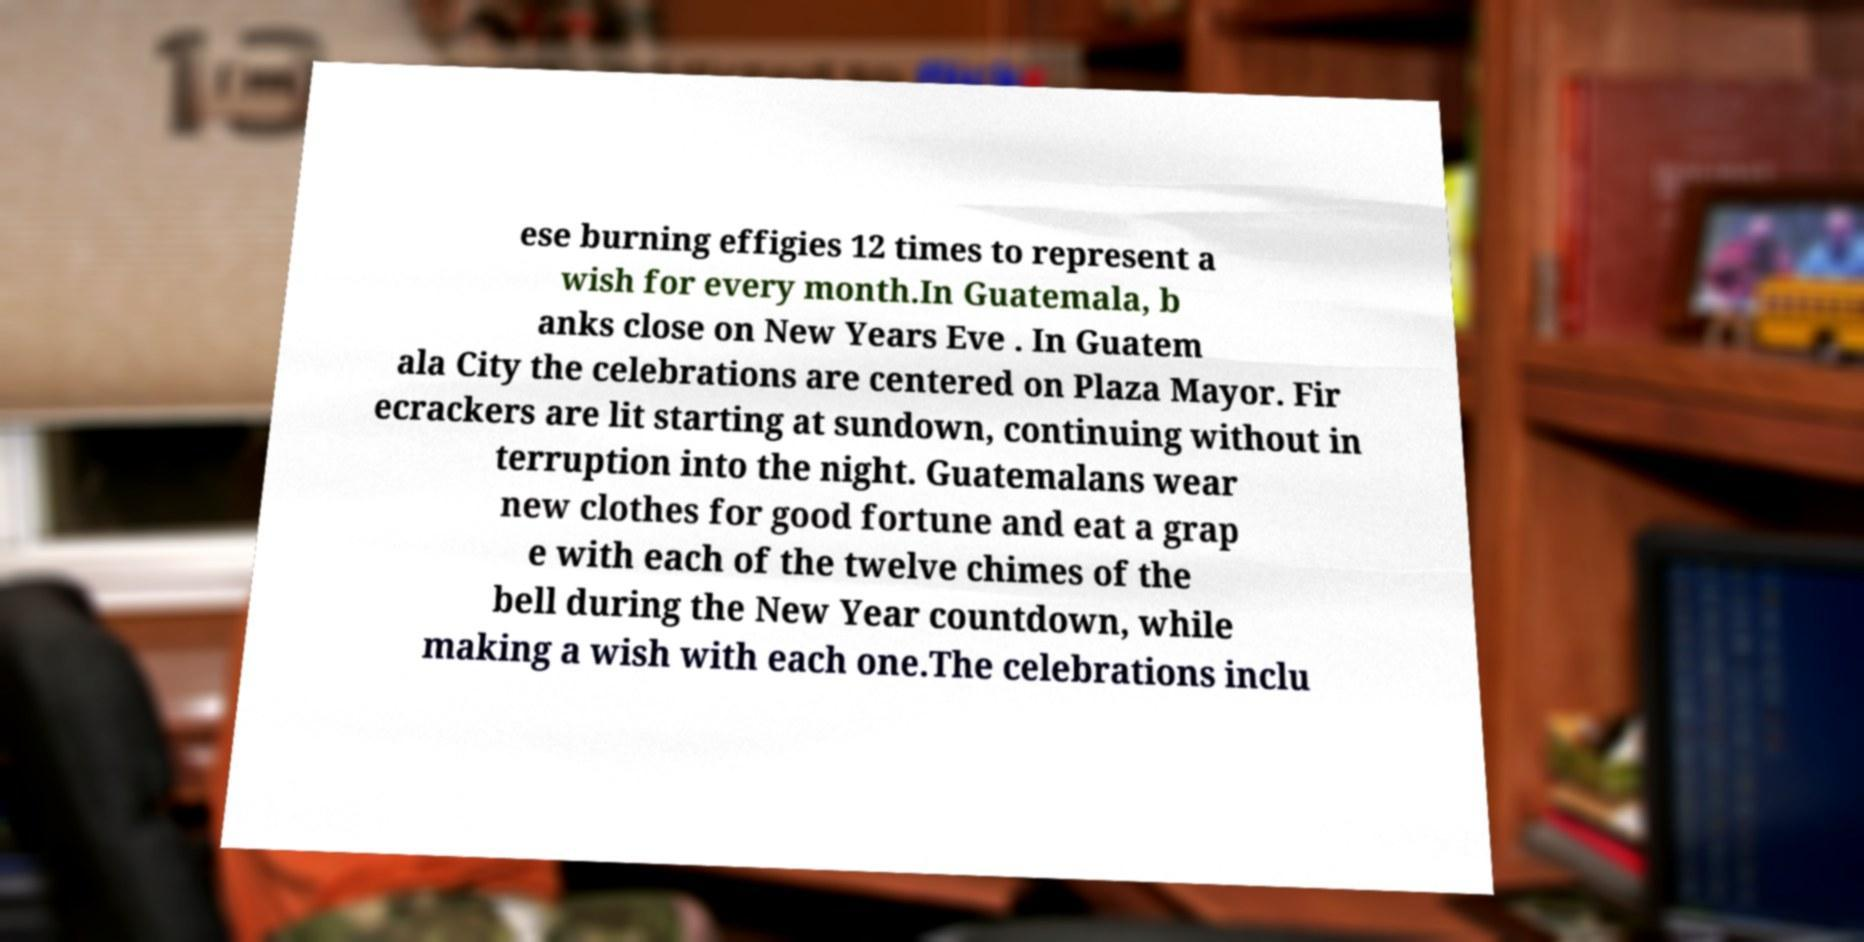Please identify and transcribe the text found in this image. ese burning effigies 12 times to represent a wish for every month.In Guatemala, b anks close on New Years Eve . In Guatem ala City the celebrations are centered on Plaza Mayor. Fir ecrackers are lit starting at sundown, continuing without in terruption into the night. Guatemalans wear new clothes for good fortune and eat a grap e with each of the twelve chimes of the bell during the New Year countdown, while making a wish with each one.The celebrations inclu 